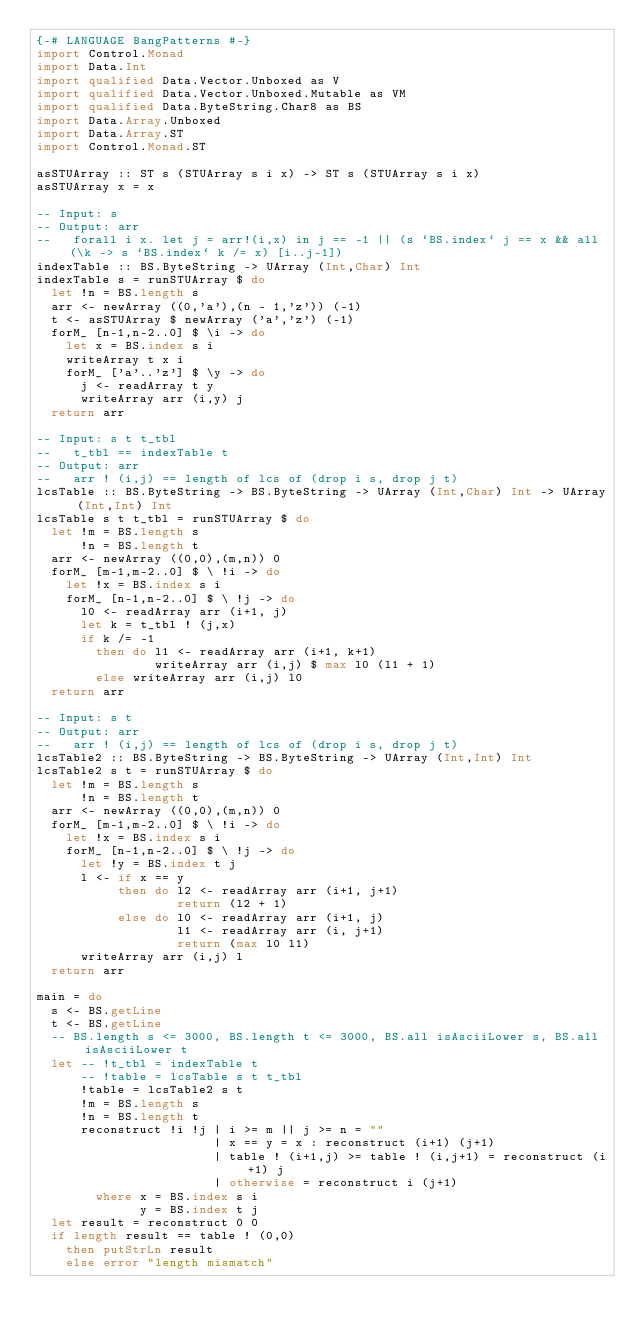Convert code to text. <code><loc_0><loc_0><loc_500><loc_500><_Haskell_>{-# LANGUAGE BangPatterns #-}
import Control.Monad
import Data.Int
import qualified Data.Vector.Unboxed as V
import qualified Data.Vector.Unboxed.Mutable as VM
import qualified Data.ByteString.Char8 as BS
import Data.Array.Unboxed
import Data.Array.ST
import Control.Monad.ST

asSTUArray :: ST s (STUArray s i x) -> ST s (STUArray s i x)
asSTUArray x = x

-- Input: s
-- Output: arr
--   forall i x. let j = arr!(i,x) in j == -1 || (s `BS.index` j == x && all (\k -> s `BS.index` k /= x) [i..j-1])
indexTable :: BS.ByteString -> UArray (Int,Char) Int
indexTable s = runSTUArray $ do
  let !n = BS.length s
  arr <- newArray ((0,'a'),(n - 1,'z')) (-1)
  t <- asSTUArray $ newArray ('a','z') (-1)
  forM_ [n-1,n-2..0] $ \i -> do
    let x = BS.index s i
    writeArray t x i
    forM_ ['a'..'z'] $ \y -> do
      j <- readArray t y
      writeArray arr (i,y) j
  return arr

-- Input: s t t_tbl
--   t_tbl == indexTable t
-- Output: arr
--   arr ! (i,j) == length of lcs of (drop i s, drop j t)
lcsTable :: BS.ByteString -> BS.ByteString -> UArray (Int,Char) Int -> UArray (Int,Int) Int
lcsTable s t t_tbl = runSTUArray $ do
  let !m = BS.length s
      !n = BS.length t
  arr <- newArray ((0,0),(m,n)) 0
  forM_ [m-1,m-2..0] $ \ !i -> do
    let !x = BS.index s i
    forM_ [n-1,n-2..0] $ \ !j -> do
      l0 <- readArray arr (i+1, j)
      let k = t_tbl ! (j,x)
      if k /= -1
        then do l1 <- readArray arr (i+1, k+1)
                writeArray arr (i,j) $ max l0 (l1 + 1)
        else writeArray arr (i,j) l0
  return arr

-- Input: s t
-- Output: arr
--   arr ! (i,j) == length of lcs of (drop i s, drop j t)
lcsTable2 :: BS.ByteString -> BS.ByteString -> UArray (Int,Int) Int
lcsTable2 s t = runSTUArray $ do
  let !m = BS.length s
      !n = BS.length t
  arr <- newArray ((0,0),(m,n)) 0
  forM_ [m-1,m-2..0] $ \ !i -> do
    let !x = BS.index s i
    forM_ [n-1,n-2..0] $ \ !j -> do
      let !y = BS.index t j
      l <- if x == y
           then do l2 <- readArray arr (i+1, j+1)
                   return (l2 + 1)
           else do l0 <- readArray arr (i+1, j)
                   l1 <- readArray arr (i, j+1)
                   return (max l0 l1)
      writeArray arr (i,j) l
  return arr

main = do
  s <- BS.getLine
  t <- BS.getLine
  -- BS.length s <= 3000, BS.length t <= 3000, BS.all isAsciiLower s, BS.all isAsciiLower t
  let -- !t_tbl = indexTable t
      -- !table = lcsTable s t t_tbl
      !table = lcsTable2 s t
      !m = BS.length s
      !n = BS.length t
      reconstruct !i !j | i >= m || j >= n = ""
                        | x == y = x : reconstruct (i+1) (j+1)
                        | table ! (i+1,j) >= table ! (i,j+1) = reconstruct (i+1) j
                        | otherwise = reconstruct i (j+1)
        where x = BS.index s i
              y = BS.index t j
  let result = reconstruct 0 0
  if length result == table ! (0,0)
    then putStrLn result
    else error "length mismatch"
</code> 